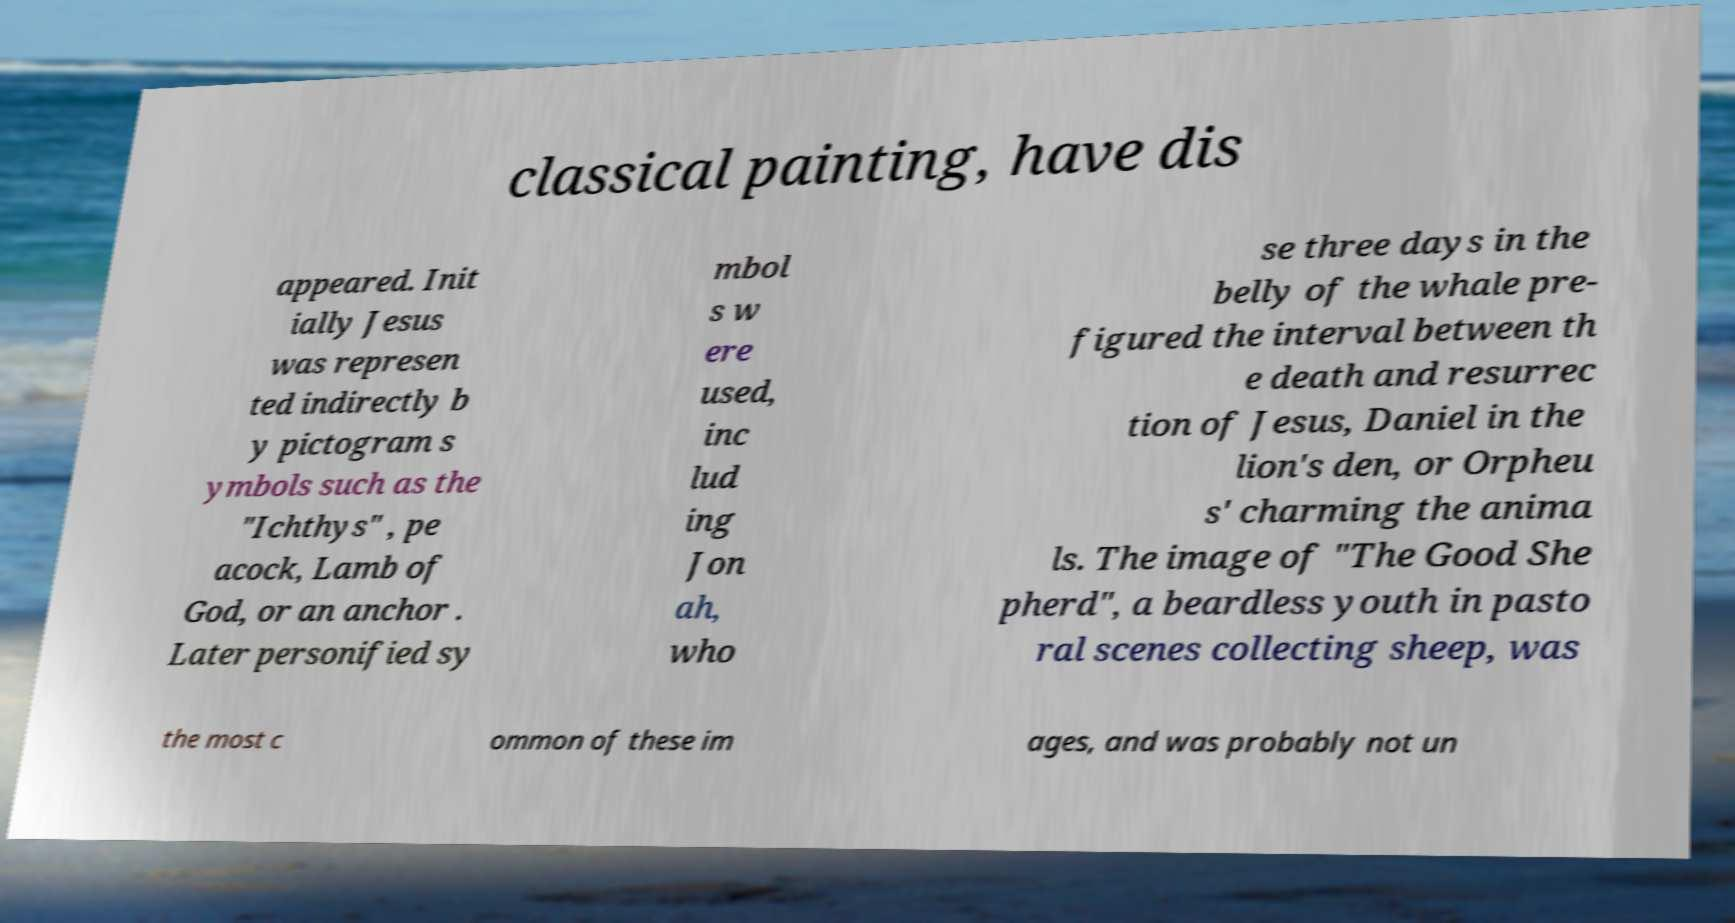I need the written content from this picture converted into text. Can you do that? classical painting, have dis appeared. Init ially Jesus was represen ted indirectly b y pictogram s ymbols such as the "Ichthys" , pe acock, Lamb of God, or an anchor . Later personified sy mbol s w ere used, inc lud ing Jon ah, who se three days in the belly of the whale pre- figured the interval between th e death and resurrec tion of Jesus, Daniel in the lion's den, or Orpheu s' charming the anima ls. The image of "The Good She pherd", a beardless youth in pasto ral scenes collecting sheep, was the most c ommon of these im ages, and was probably not un 